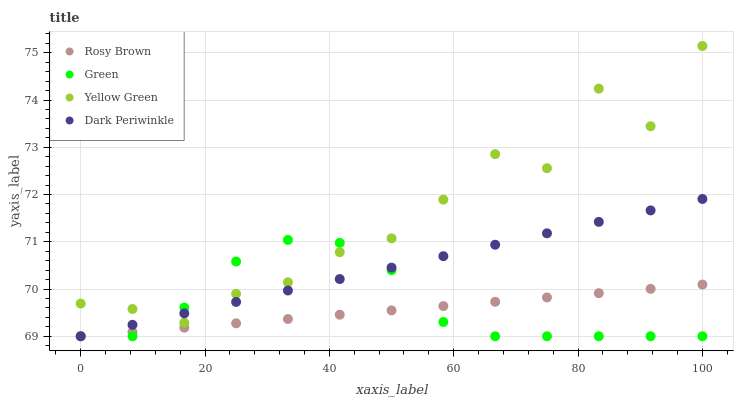Does Rosy Brown have the minimum area under the curve?
Answer yes or no. Yes. Does Yellow Green have the maximum area under the curve?
Answer yes or no. Yes. Does Green have the minimum area under the curve?
Answer yes or no. No. Does Green have the maximum area under the curve?
Answer yes or no. No. Is Rosy Brown the smoothest?
Answer yes or no. Yes. Is Yellow Green the roughest?
Answer yes or no. Yes. Is Green the smoothest?
Answer yes or no. No. Is Green the roughest?
Answer yes or no. No. Does Rosy Brown have the lowest value?
Answer yes or no. Yes. Does Yellow Green have the lowest value?
Answer yes or no. No. Does Yellow Green have the highest value?
Answer yes or no. Yes. Does Green have the highest value?
Answer yes or no. No. Is Rosy Brown less than Yellow Green?
Answer yes or no. Yes. Is Yellow Green greater than Rosy Brown?
Answer yes or no. Yes. Does Rosy Brown intersect Dark Periwinkle?
Answer yes or no. Yes. Is Rosy Brown less than Dark Periwinkle?
Answer yes or no. No. Is Rosy Brown greater than Dark Periwinkle?
Answer yes or no. No. Does Rosy Brown intersect Yellow Green?
Answer yes or no. No. 